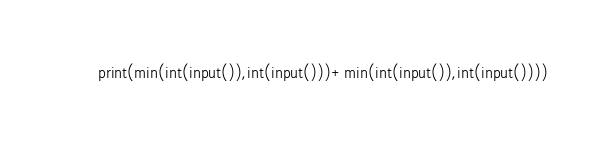Convert code to text. <code><loc_0><loc_0><loc_500><loc_500><_Python_>print(min(int(input()),int(input()))+min(int(input()),int(input())))</code> 